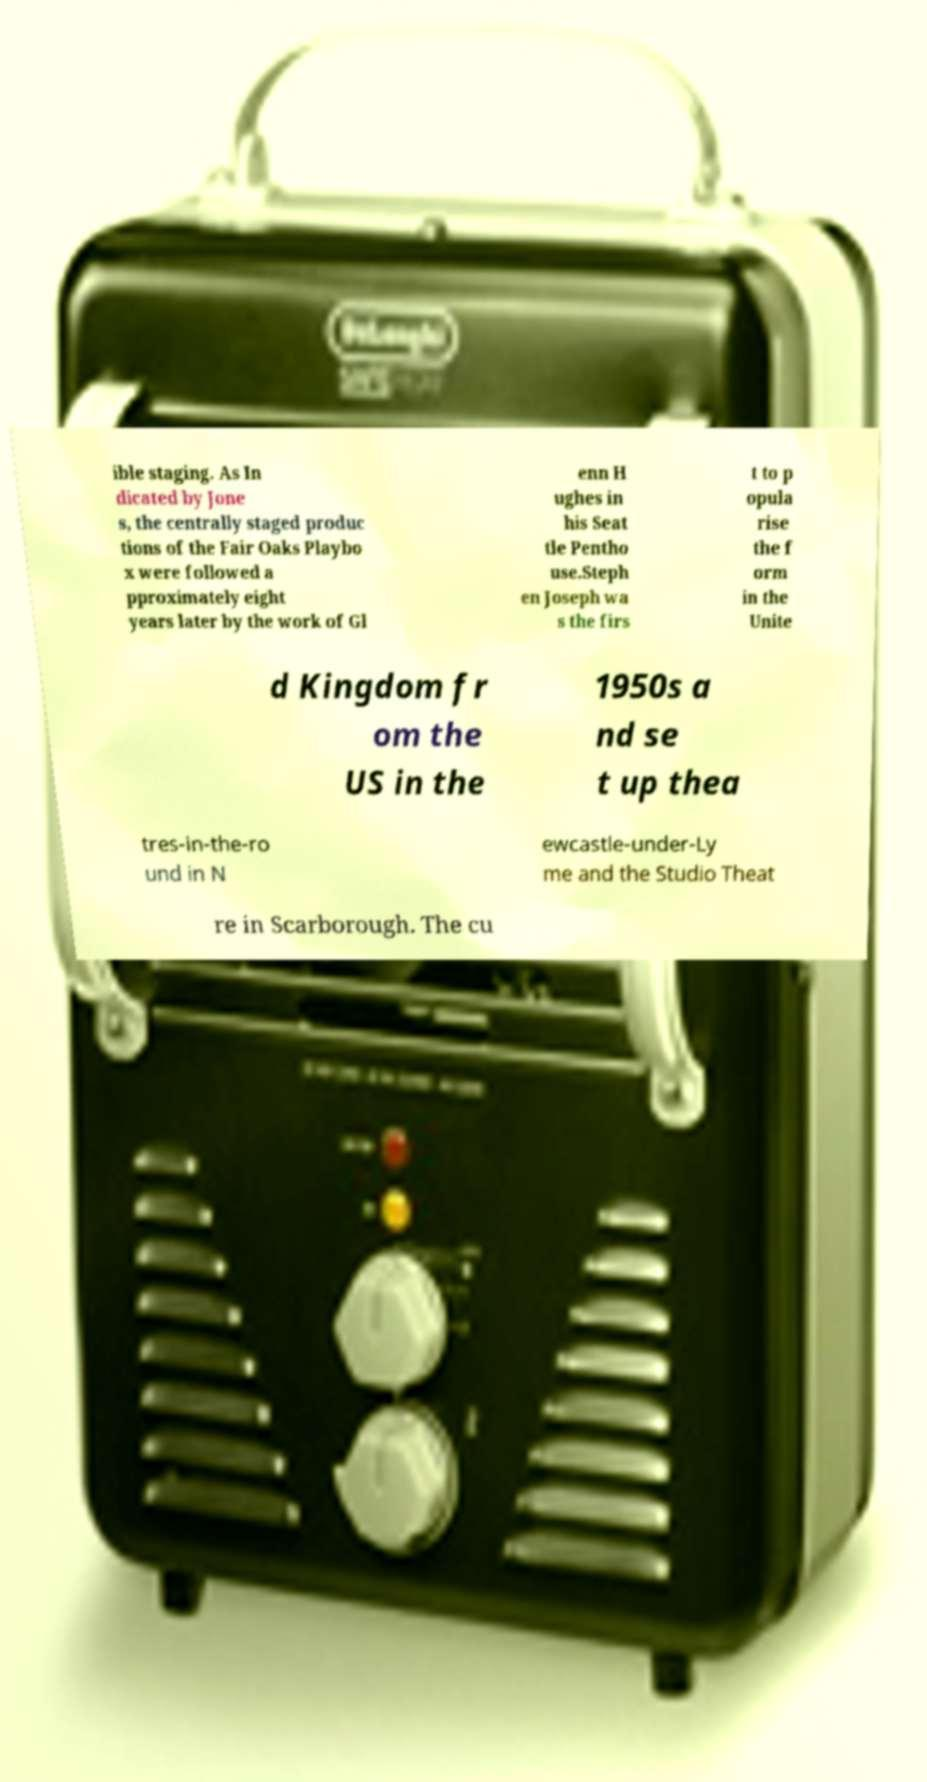Can you read and provide the text displayed in the image?This photo seems to have some interesting text. Can you extract and type it out for me? ible staging. As In dicated by Jone s, the centrally staged produc tions of the Fair Oaks Playbo x were followed a pproximately eight years later by the work of Gl enn H ughes in his Seat tle Pentho use.Steph en Joseph wa s the firs t to p opula rise the f orm in the Unite d Kingdom fr om the US in the 1950s a nd se t up thea tres-in-the-ro und in N ewcastle-under-Ly me and the Studio Theat re in Scarborough. The cu 